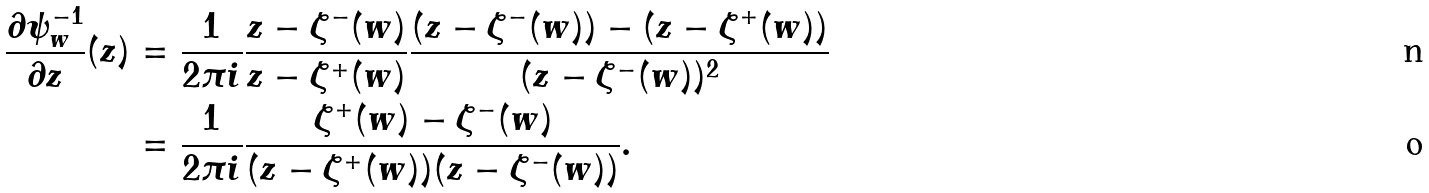Convert formula to latex. <formula><loc_0><loc_0><loc_500><loc_500>\frac { \partial \psi _ { w } ^ { - 1 } } { \partial z } ( z ) & = \frac { 1 } { 2 \pi i } \frac { z - \zeta ^ { - } ( w ) } { z - \zeta ^ { + } ( w ) } \frac { ( z - \zeta ^ { - } ( w ) ) - ( z - \zeta ^ { + } ( w ) ) } { ( z - \zeta ^ { - } ( w ) ) ^ { 2 } } \\ & = \frac { 1 } { 2 \pi i } \frac { \zeta ^ { + } ( w ) - \zeta ^ { - } ( w ) } { ( z - \zeta ^ { + } ( w ) ) ( z - \zeta ^ { - } ( w ) ) } .</formula> 